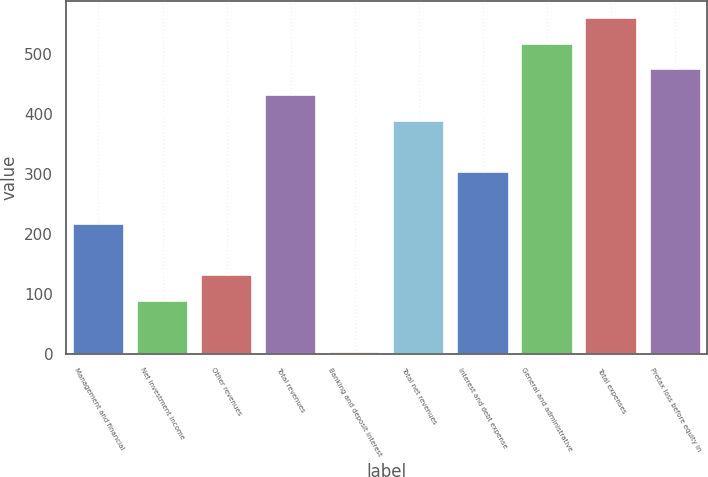Convert chart to OTSL. <chart><loc_0><loc_0><loc_500><loc_500><bar_chart><fcel>Management and financial<fcel>Net investment income<fcel>Other revenues<fcel>Total revenues<fcel>Banking and deposit interest<fcel>Total net revenues<fcel>Interest and debt expense<fcel>General and administrative<fcel>Total expenses<fcel>Pretax loss before equity in<nl><fcel>216.5<fcel>87.8<fcel>130.7<fcel>431<fcel>2<fcel>388.1<fcel>302.3<fcel>516.8<fcel>559.7<fcel>473.9<nl></chart> 